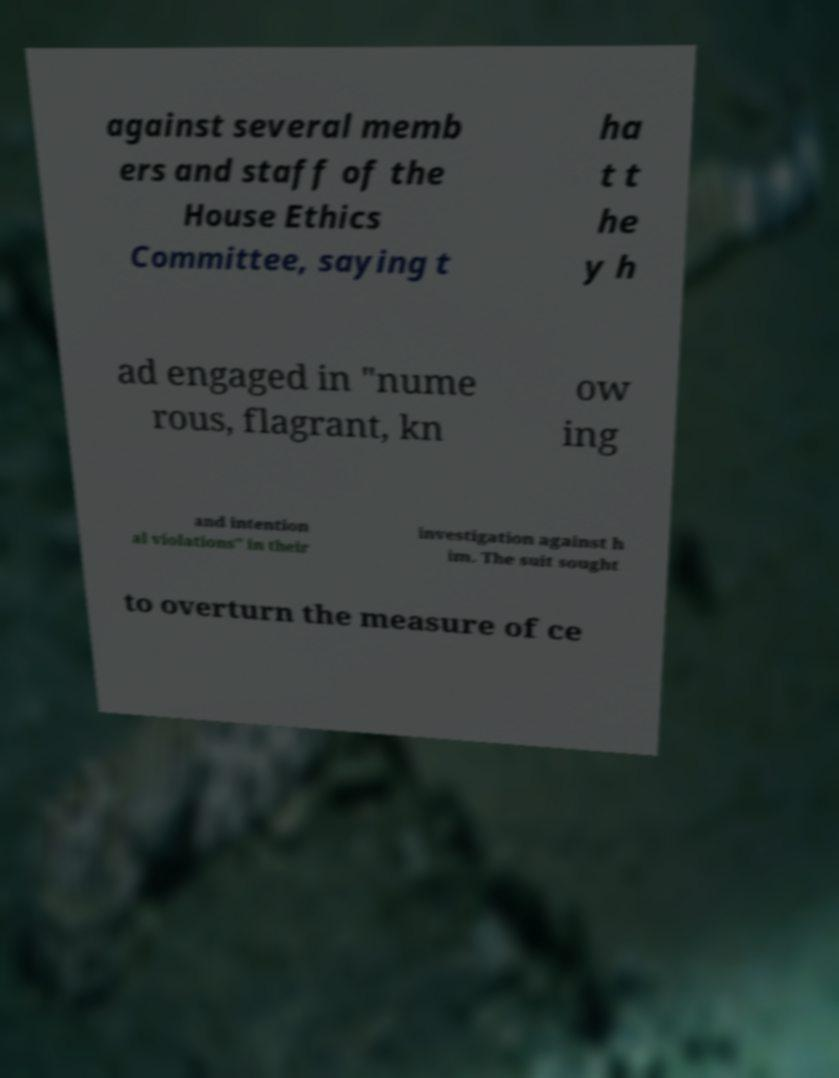I need the written content from this picture converted into text. Can you do that? against several memb ers and staff of the House Ethics Committee, saying t ha t t he y h ad engaged in "nume rous, flagrant, kn ow ing and intention al violations" in their investigation against h im. The suit sought to overturn the measure of ce 